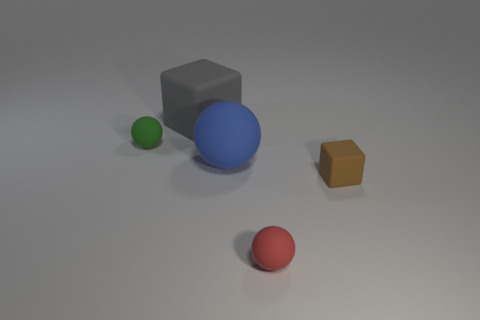Add 4 small rubber balls. How many objects exist? 9 Subtract all balls. How many objects are left? 2 Add 2 large cyan metal cylinders. How many large cyan metal cylinders exist? 2 Subtract 0 blue cylinders. How many objects are left? 5 Subtract all brown things. Subtract all big red metallic cubes. How many objects are left? 4 Add 2 big gray matte blocks. How many big gray matte blocks are left? 3 